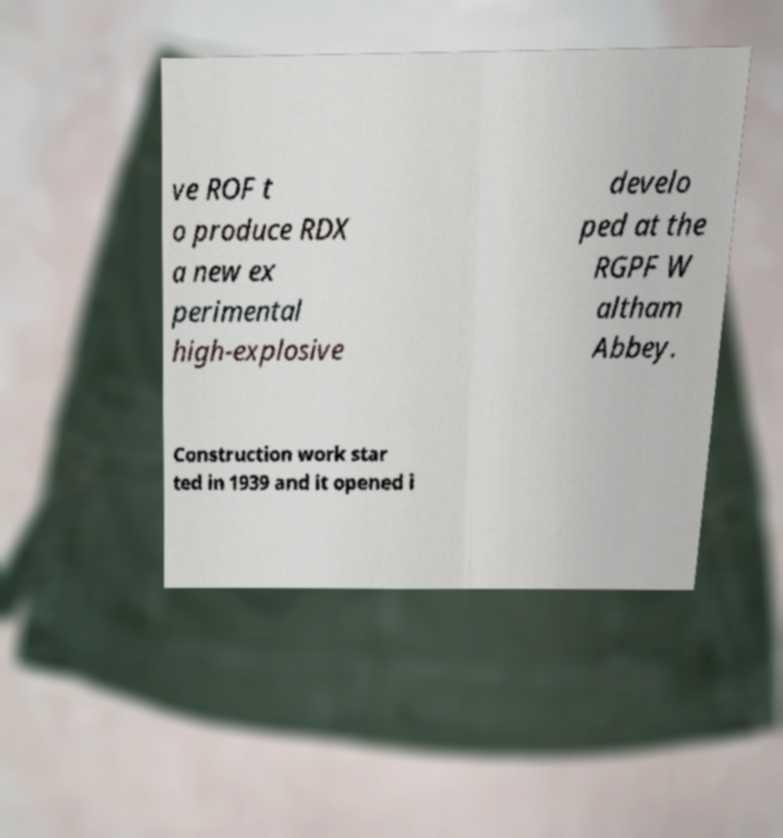Could you assist in decoding the text presented in this image and type it out clearly? ve ROF t o produce RDX a new ex perimental high-explosive develo ped at the RGPF W altham Abbey. Construction work star ted in 1939 and it opened i 